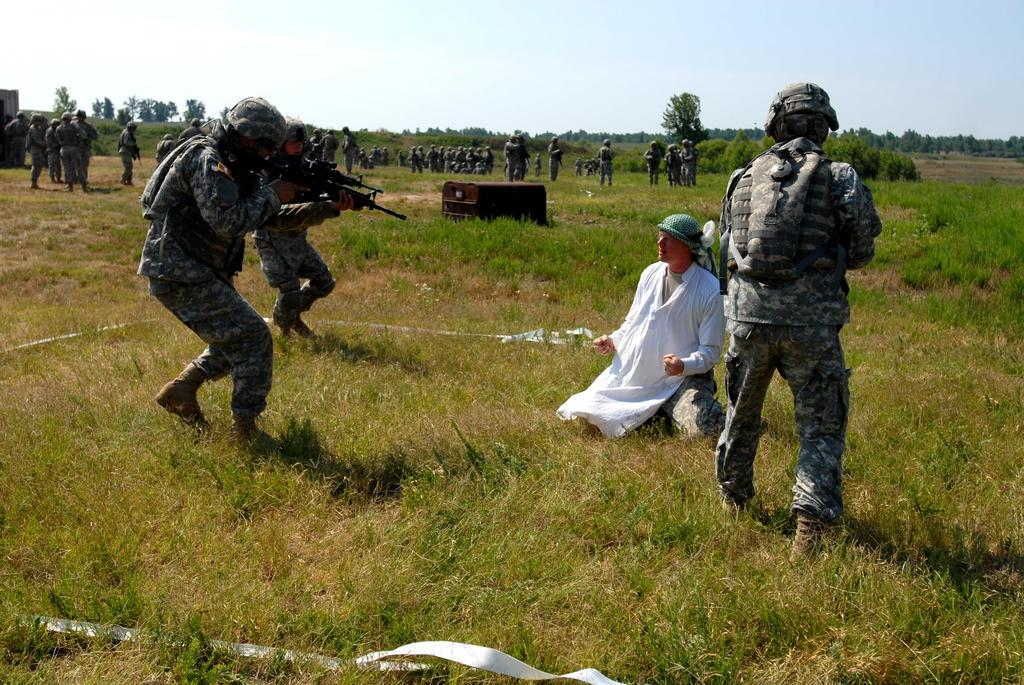How many people are in the image? There is a group of people in the image, but the exact number cannot be determined from the provided facts. What is the position of the people in the image? The people are on the ground in the image. What can be seen in the background of the image? There are trees, sky, and some objects visible in the background of the image. What type of company is being advertised by the tomatoes in the image? There are no tomatoes present in the image, so it is not possible to answer that question. 